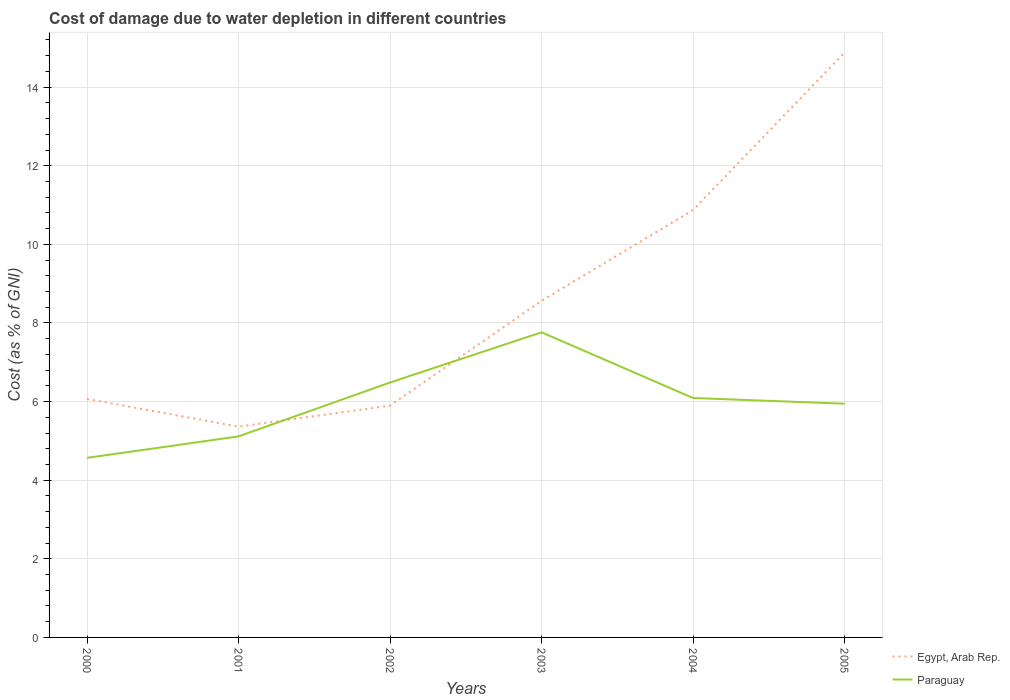Is the number of lines equal to the number of legend labels?
Offer a terse response. Yes. Across all years, what is the maximum cost of damage caused due to water depletion in Paraguay?
Ensure brevity in your answer.  4.57. What is the total cost of damage caused due to water depletion in Paraguay in the graph?
Provide a succinct answer. -3.19. What is the difference between the highest and the second highest cost of damage caused due to water depletion in Egypt, Arab Rep.?
Offer a very short reply. 9.52. Is the cost of damage caused due to water depletion in Paraguay strictly greater than the cost of damage caused due to water depletion in Egypt, Arab Rep. over the years?
Your response must be concise. No. Are the values on the major ticks of Y-axis written in scientific E-notation?
Offer a very short reply. No. Does the graph contain any zero values?
Make the answer very short. No. Does the graph contain grids?
Provide a succinct answer. Yes. How are the legend labels stacked?
Offer a terse response. Vertical. What is the title of the graph?
Your answer should be very brief. Cost of damage due to water depletion in different countries. What is the label or title of the X-axis?
Make the answer very short. Years. What is the label or title of the Y-axis?
Your answer should be compact. Cost (as % of GNI). What is the Cost (as % of GNI) in Egypt, Arab Rep. in 2000?
Provide a succinct answer. 6.07. What is the Cost (as % of GNI) of Paraguay in 2000?
Your response must be concise. 4.57. What is the Cost (as % of GNI) in Egypt, Arab Rep. in 2001?
Offer a very short reply. 5.36. What is the Cost (as % of GNI) of Paraguay in 2001?
Make the answer very short. 5.11. What is the Cost (as % of GNI) of Egypt, Arab Rep. in 2002?
Give a very brief answer. 5.9. What is the Cost (as % of GNI) in Paraguay in 2002?
Your response must be concise. 6.49. What is the Cost (as % of GNI) of Egypt, Arab Rep. in 2003?
Give a very brief answer. 8.56. What is the Cost (as % of GNI) of Paraguay in 2003?
Provide a short and direct response. 7.76. What is the Cost (as % of GNI) of Egypt, Arab Rep. in 2004?
Give a very brief answer. 10.87. What is the Cost (as % of GNI) in Paraguay in 2004?
Offer a terse response. 6.09. What is the Cost (as % of GNI) of Egypt, Arab Rep. in 2005?
Keep it short and to the point. 14.88. What is the Cost (as % of GNI) in Paraguay in 2005?
Your answer should be very brief. 5.95. Across all years, what is the maximum Cost (as % of GNI) in Egypt, Arab Rep.?
Offer a terse response. 14.88. Across all years, what is the maximum Cost (as % of GNI) in Paraguay?
Your answer should be very brief. 7.76. Across all years, what is the minimum Cost (as % of GNI) of Egypt, Arab Rep.?
Your response must be concise. 5.36. Across all years, what is the minimum Cost (as % of GNI) of Paraguay?
Keep it short and to the point. 4.57. What is the total Cost (as % of GNI) in Egypt, Arab Rep. in the graph?
Your answer should be very brief. 51.65. What is the total Cost (as % of GNI) in Paraguay in the graph?
Provide a short and direct response. 35.97. What is the difference between the Cost (as % of GNI) in Egypt, Arab Rep. in 2000 and that in 2001?
Make the answer very short. 0.7. What is the difference between the Cost (as % of GNI) of Paraguay in 2000 and that in 2001?
Your answer should be very brief. -0.55. What is the difference between the Cost (as % of GNI) in Egypt, Arab Rep. in 2000 and that in 2002?
Make the answer very short. 0.17. What is the difference between the Cost (as % of GNI) in Paraguay in 2000 and that in 2002?
Provide a short and direct response. -1.92. What is the difference between the Cost (as % of GNI) in Egypt, Arab Rep. in 2000 and that in 2003?
Your response must be concise. -2.5. What is the difference between the Cost (as % of GNI) of Paraguay in 2000 and that in 2003?
Offer a terse response. -3.19. What is the difference between the Cost (as % of GNI) in Egypt, Arab Rep. in 2000 and that in 2004?
Offer a very short reply. -4.81. What is the difference between the Cost (as % of GNI) of Paraguay in 2000 and that in 2004?
Make the answer very short. -1.52. What is the difference between the Cost (as % of GNI) in Egypt, Arab Rep. in 2000 and that in 2005?
Your answer should be compact. -8.81. What is the difference between the Cost (as % of GNI) in Paraguay in 2000 and that in 2005?
Offer a very short reply. -1.38. What is the difference between the Cost (as % of GNI) of Egypt, Arab Rep. in 2001 and that in 2002?
Offer a terse response. -0.54. What is the difference between the Cost (as % of GNI) in Paraguay in 2001 and that in 2002?
Provide a short and direct response. -1.37. What is the difference between the Cost (as % of GNI) in Egypt, Arab Rep. in 2001 and that in 2003?
Ensure brevity in your answer.  -3.2. What is the difference between the Cost (as % of GNI) in Paraguay in 2001 and that in 2003?
Offer a very short reply. -2.65. What is the difference between the Cost (as % of GNI) in Egypt, Arab Rep. in 2001 and that in 2004?
Provide a short and direct response. -5.51. What is the difference between the Cost (as % of GNI) in Paraguay in 2001 and that in 2004?
Your response must be concise. -0.98. What is the difference between the Cost (as % of GNI) of Egypt, Arab Rep. in 2001 and that in 2005?
Provide a succinct answer. -9.52. What is the difference between the Cost (as % of GNI) in Paraguay in 2001 and that in 2005?
Offer a terse response. -0.83. What is the difference between the Cost (as % of GNI) in Egypt, Arab Rep. in 2002 and that in 2003?
Your answer should be compact. -2.67. What is the difference between the Cost (as % of GNI) in Paraguay in 2002 and that in 2003?
Offer a very short reply. -1.28. What is the difference between the Cost (as % of GNI) of Egypt, Arab Rep. in 2002 and that in 2004?
Ensure brevity in your answer.  -4.98. What is the difference between the Cost (as % of GNI) of Paraguay in 2002 and that in 2004?
Offer a very short reply. 0.39. What is the difference between the Cost (as % of GNI) in Egypt, Arab Rep. in 2002 and that in 2005?
Ensure brevity in your answer.  -8.98. What is the difference between the Cost (as % of GNI) in Paraguay in 2002 and that in 2005?
Make the answer very short. 0.54. What is the difference between the Cost (as % of GNI) of Egypt, Arab Rep. in 2003 and that in 2004?
Provide a short and direct response. -2.31. What is the difference between the Cost (as % of GNI) of Paraguay in 2003 and that in 2004?
Provide a succinct answer. 1.67. What is the difference between the Cost (as % of GNI) in Egypt, Arab Rep. in 2003 and that in 2005?
Your response must be concise. -6.32. What is the difference between the Cost (as % of GNI) in Paraguay in 2003 and that in 2005?
Provide a short and direct response. 1.82. What is the difference between the Cost (as % of GNI) of Egypt, Arab Rep. in 2004 and that in 2005?
Offer a very short reply. -4.01. What is the difference between the Cost (as % of GNI) of Paraguay in 2004 and that in 2005?
Offer a terse response. 0.15. What is the difference between the Cost (as % of GNI) in Egypt, Arab Rep. in 2000 and the Cost (as % of GNI) in Paraguay in 2001?
Your response must be concise. 0.95. What is the difference between the Cost (as % of GNI) of Egypt, Arab Rep. in 2000 and the Cost (as % of GNI) of Paraguay in 2002?
Make the answer very short. -0.42. What is the difference between the Cost (as % of GNI) in Egypt, Arab Rep. in 2000 and the Cost (as % of GNI) in Paraguay in 2003?
Offer a terse response. -1.7. What is the difference between the Cost (as % of GNI) in Egypt, Arab Rep. in 2000 and the Cost (as % of GNI) in Paraguay in 2004?
Ensure brevity in your answer.  -0.02. What is the difference between the Cost (as % of GNI) in Egypt, Arab Rep. in 2000 and the Cost (as % of GNI) in Paraguay in 2005?
Provide a succinct answer. 0.12. What is the difference between the Cost (as % of GNI) of Egypt, Arab Rep. in 2001 and the Cost (as % of GNI) of Paraguay in 2002?
Offer a very short reply. -1.12. What is the difference between the Cost (as % of GNI) in Egypt, Arab Rep. in 2001 and the Cost (as % of GNI) in Paraguay in 2003?
Give a very brief answer. -2.4. What is the difference between the Cost (as % of GNI) of Egypt, Arab Rep. in 2001 and the Cost (as % of GNI) of Paraguay in 2004?
Provide a succinct answer. -0.73. What is the difference between the Cost (as % of GNI) of Egypt, Arab Rep. in 2001 and the Cost (as % of GNI) of Paraguay in 2005?
Offer a very short reply. -0.58. What is the difference between the Cost (as % of GNI) of Egypt, Arab Rep. in 2002 and the Cost (as % of GNI) of Paraguay in 2003?
Your answer should be compact. -1.86. What is the difference between the Cost (as % of GNI) in Egypt, Arab Rep. in 2002 and the Cost (as % of GNI) in Paraguay in 2004?
Provide a short and direct response. -0.19. What is the difference between the Cost (as % of GNI) in Egypt, Arab Rep. in 2002 and the Cost (as % of GNI) in Paraguay in 2005?
Your response must be concise. -0.05. What is the difference between the Cost (as % of GNI) in Egypt, Arab Rep. in 2003 and the Cost (as % of GNI) in Paraguay in 2004?
Your response must be concise. 2.47. What is the difference between the Cost (as % of GNI) of Egypt, Arab Rep. in 2003 and the Cost (as % of GNI) of Paraguay in 2005?
Ensure brevity in your answer.  2.62. What is the difference between the Cost (as % of GNI) in Egypt, Arab Rep. in 2004 and the Cost (as % of GNI) in Paraguay in 2005?
Offer a very short reply. 4.93. What is the average Cost (as % of GNI) in Egypt, Arab Rep. per year?
Ensure brevity in your answer.  8.61. What is the average Cost (as % of GNI) in Paraguay per year?
Offer a terse response. 6. In the year 2000, what is the difference between the Cost (as % of GNI) in Egypt, Arab Rep. and Cost (as % of GNI) in Paraguay?
Your answer should be very brief. 1.5. In the year 2001, what is the difference between the Cost (as % of GNI) of Egypt, Arab Rep. and Cost (as % of GNI) of Paraguay?
Offer a very short reply. 0.25. In the year 2002, what is the difference between the Cost (as % of GNI) of Egypt, Arab Rep. and Cost (as % of GNI) of Paraguay?
Provide a succinct answer. -0.59. In the year 2003, what is the difference between the Cost (as % of GNI) of Egypt, Arab Rep. and Cost (as % of GNI) of Paraguay?
Your response must be concise. 0.8. In the year 2004, what is the difference between the Cost (as % of GNI) in Egypt, Arab Rep. and Cost (as % of GNI) in Paraguay?
Ensure brevity in your answer.  4.78. In the year 2005, what is the difference between the Cost (as % of GNI) in Egypt, Arab Rep. and Cost (as % of GNI) in Paraguay?
Provide a succinct answer. 8.93. What is the ratio of the Cost (as % of GNI) of Egypt, Arab Rep. in 2000 to that in 2001?
Provide a succinct answer. 1.13. What is the ratio of the Cost (as % of GNI) of Paraguay in 2000 to that in 2001?
Keep it short and to the point. 0.89. What is the ratio of the Cost (as % of GNI) in Egypt, Arab Rep. in 2000 to that in 2002?
Ensure brevity in your answer.  1.03. What is the ratio of the Cost (as % of GNI) of Paraguay in 2000 to that in 2002?
Your response must be concise. 0.7. What is the ratio of the Cost (as % of GNI) in Egypt, Arab Rep. in 2000 to that in 2003?
Your answer should be compact. 0.71. What is the ratio of the Cost (as % of GNI) of Paraguay in 2000 to that in 2003?
Your answer should be very brief. 0.59. What is the ratio of the Cost (as % of GNI) of Egypt, Arab Rep. in 2000 to that in 2004?
Provide a succinct answer. 0.56. What is the ratio of the Cost (as % of GNI) in Paraguay in 2000 to that in 2004?
Ensure brevity in your answer.  0.75. What is the ratio of the Cost (as % of GNI) in Egypt, Arab Rep. in 2000 to that in 2005?
Your answer should be very brief. 0.41. What is the ratio of the Cost (as % of GNI) of Paraguay in 2000 to that in 2005?
Your answer should be very brief. 0.77. What is the ratio of the Cost (as % of GNI) in Egypt, Arab Rep. in 2001 to that in 2002?
Keep it short and to the point. 0.91. What is the ratio of the Cost (as % of GNI) in Paraguay in 2001 to that in 2002?
Give a very brief answer. 0.79. What is the ratio of the Cost (as % of GNI) in Egypt, Arab Rep. in 2001 to that in 2003?
Your answer should be very brief. 0.63. What is the ratio of the Cost (as % of GNI) in Paraguay in 2001 to that in 2003?
Provide a short and direct response. 0.66. What is the ratio of the Cost (as % of GNI) of Egypt, Arab Rep. in 2001 to that in 2004?
Offer a terse response. 0.49. What is the ratio of the Cost (as % of GNI) of Paraguay in 2001 to that in 2004?
Your answer should be very brief. 0.84. What is the ratio of the Cost (as % of GNI) of Egypt, Arab Rep. in 2001 to that in 2005?
Keep it short and to the point. 0.36. What is the ratio of the Cost (as % of GNI) of Paraguay in 2001 to that in 2005?
Your answer should be very brief. 0.86. What is the ratio of the Cost (as % of GNI) of Egypt, Arab Rep. in 2002 to that in 2003?
Provide a short and direct response. 0.69. What is the ratio of the Cost (as % of GNI) in Paraguay in 2002 to that in 2003?
Your answer should be very brief. 0.84. What is the ratio of the Cost (as % of GNI) in Egypt, Arab Rep. in 2002 to that in 2004?
Offer a very short reply. 0.54. What is the ratio of the Cost (as % of GNI) in Paraguay in 2002 to that in 2004?
Provide a succinct answer. 1.06. What is the ratio of the Cost (as % of GNI) in Egypt, Arab Rep. in 2002 to that in 2005?
Your answer should be compact. 0.4. What is the ratio of the Cost (as % of GNI) in Paraguay in 2002 to that in 2005?
Offer a terse response. 1.09. What is the ratio of the Cost (as % of GNI) in Egypt, Arab Rep. in 2003 to that in 2004?
Offer a terse response. 0.79. What is the ratio of the Cost (as % of GNI) in Paraguay in 2003 to that in 2004?
Keep it short and to the point. 1.27. What is the ratio of the Cost (as % of GNI) in Egypt, Arab Rep. in 2003 to that in 2005?
Make the answer very short. 0.58. What is the ratio of the Cost (as % of GNI) in Paraguay in 2003 to that in 2005?
Give a very brief answer. 1.31. What is the ratio of the Cost (as % of GNI) in Egypt, Arab Rep. in 2004 to that in 2005?
Your answer should be very brief. 0.73. What is the ratio of the Cost (as % of GNI) in Paraguay in 2004 to that in 2005?
Offer a very short reply. 1.02. What is the difference between the highest and the second highest Cost (as % of GNI) of Egypt, Arab Rep.?
Offer a very short reply. 4.01. What is the difference between the highest and the second highest Cost (as % of GNI) of Paraguay?
Provide a short and direct response. 1.28. What is the difference between the highest and the lowest Cost (as % of GNI) in Egypt, Arab Rep.?
Your answer should be very brief. 9.52. What is the difference between the highest and the lowest Cost (as % of GNI) in Paraguay?
Your answer should be compact. 3.19. 